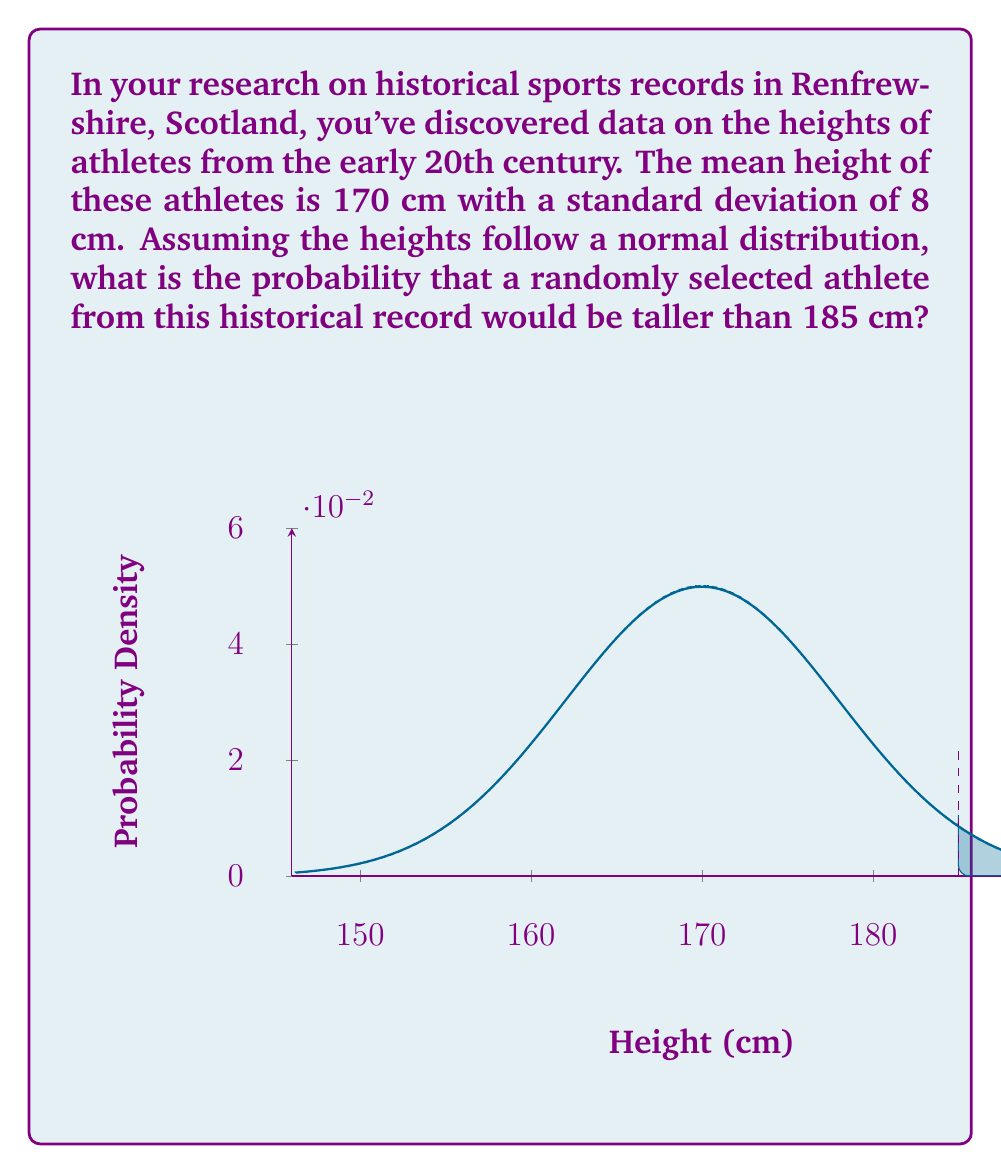Help me with this question. To solve this problem, we'll follow these steps:

1) First, we need to standardize the given value to calculate the z-score:

   $$z = \frac{x - \mu}{\sigma}$$

   Where:
   $x$ = 185 cm (the height we're interested in)
   $\mu$ = 170 cm (the mean height)
   $\sigma$ = 8 cm (the standard deviation)

   $$z = \frac{185 - 170}{8} = \frac{15}{8} = 1.875$$

2) Now that we have the z-score, we need to find the area to the right of this z-score in the standard normal distribution. This represents the probability of an athlete being taller than 185 cm.

3) We can use a standard normal distribution table or a calculator for this. The area to the right of z = 1.875 is approximately 0.0304.

4) Therefore, the probability of a randomly selected athlete being taller than 185 cm is about 0.0304 or 3.04%.

This result tells us that based on the historical records, only about 3% of athletes in early 20th century Renfrewshire were taller than 185 cm, which might be an interesting fact for your local sports history research.
Answer: 0.0304 or 3.04% 